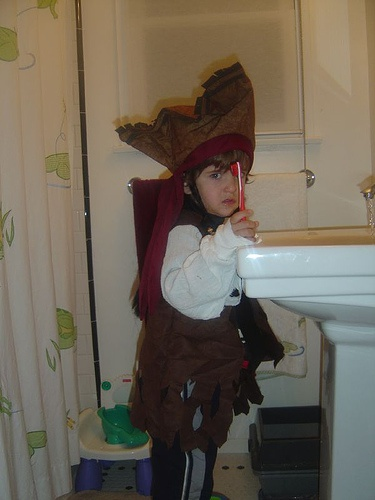Describe the objects in this image and their specific colors. I can see people in gray, black, darkgray, and maroon tones, sink in gray, darkgray, and lightblue tones, toilet in gray, black, darkgreen, and navy tones, and toothbrush in gray, brown, maroon, and lightpink tones in this image. 